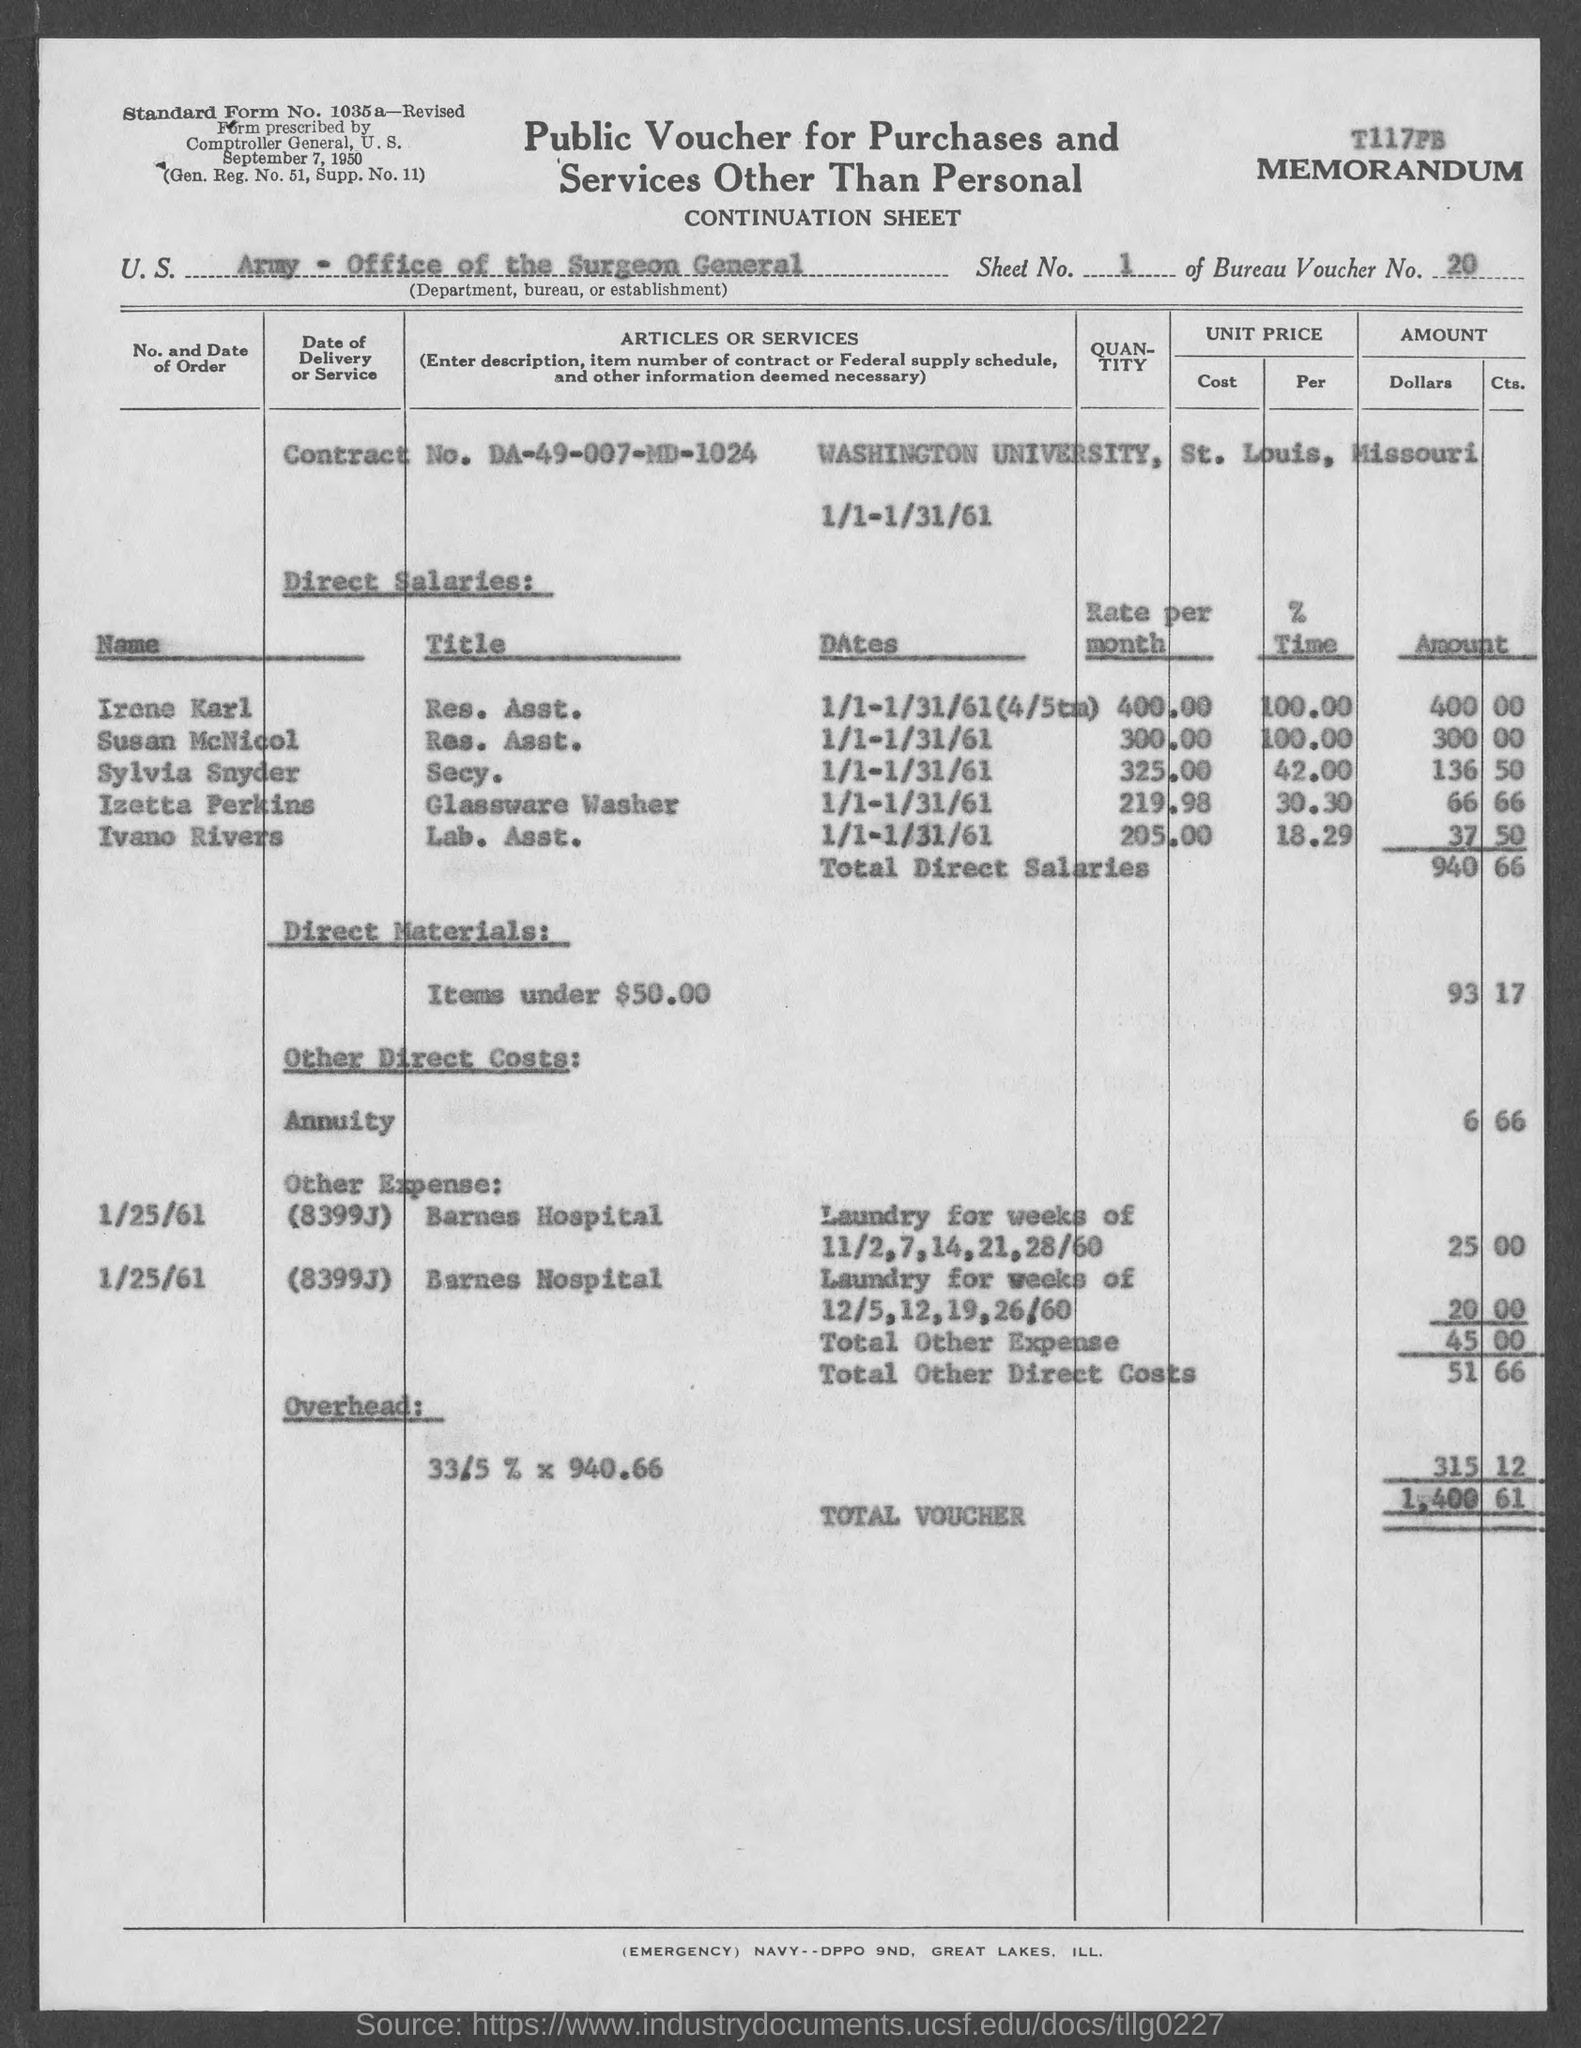Give some essential details in this illustration. The memorandum contains a contract number, which is DA-49-007-MD-1024. The total amount mentioned against the "total voucher" is 1,400 dollars and 61 cents. The Bureau Voucher Number mentioned in the Memorandum is 20... The hospital that is mentioned under the "other expenses" is Barnes Hospital. The memorandum mentions Washington University. 